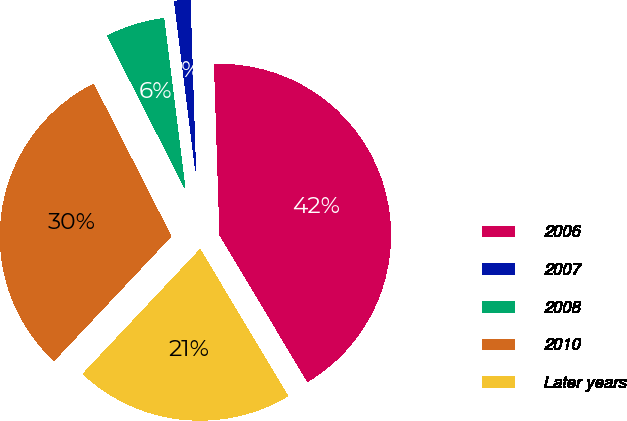<chart> <loc_0><loc_0><loc_500><loc_500><pie_chart><fcel>2006<fcel>2007<fcel>2008<fcel>2010<fcel>Later years<nl><fcel>41.93%<fcel>1.47%<fcel>5.52%<fcel>30.49%<fcel>20.6%<nl></chart> 